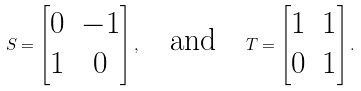<formula> <loc_0><loc_0><loc_500><loc_500>S = \begin{bmatrix} 0 & - 1 \\ 1 & 0 \end{bmatrix} , \quad \text {and} \quad T = \begin{bmatrix} 1 & 1 \\ 0 & 1 \end{bmatrix} .</formula> 